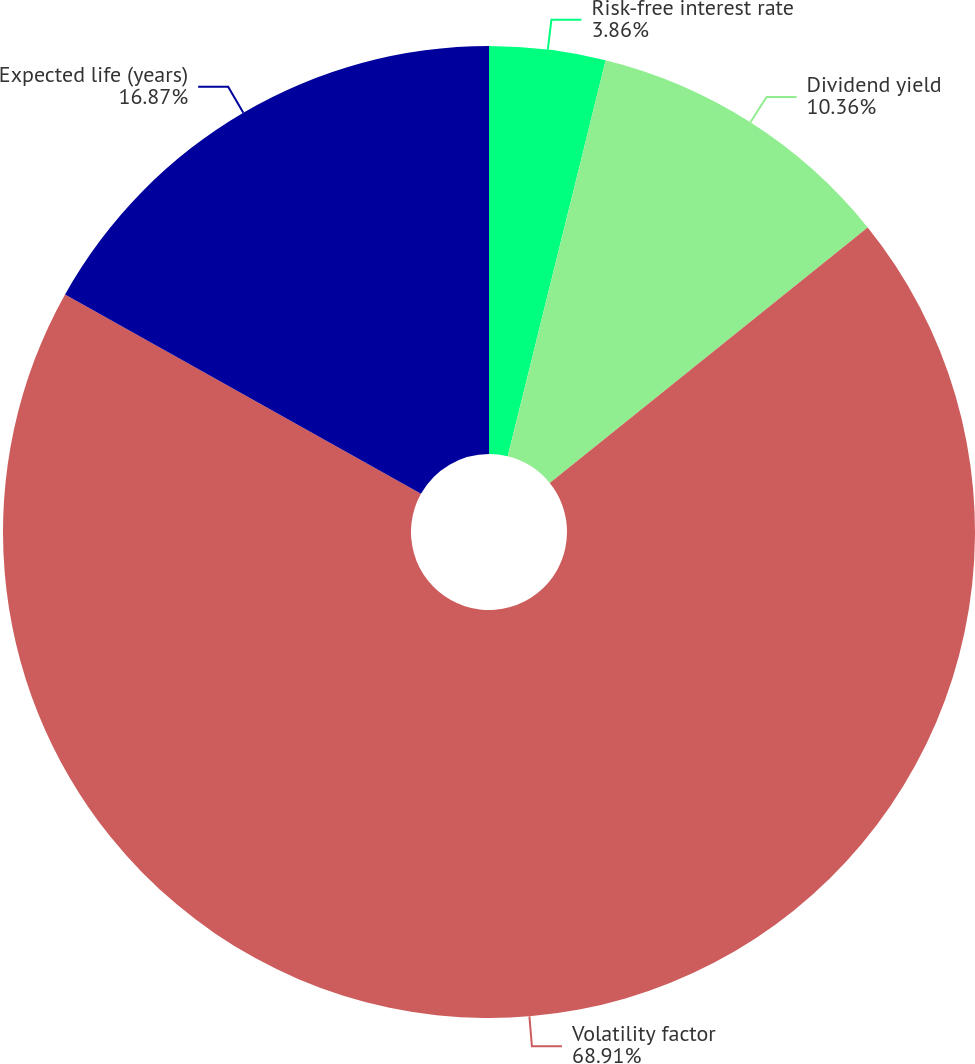<chart> <loc_0><loc_0><loc_500><loc_500><pie_chart><fcel>Risk-free interest rate<fcel>Dividend yield<fcel>Volatility factor<fcel>Expected life (years)<nl><fcel>3.86%<fcel>10.36%<fcel>68.91%<fcel>16.87%<nl></chart> 